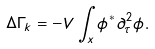<formula> <loc_0><loc_0><loc_500><loc_500>\Delta \Gamma _ { k } = - V \int _ { x } \phi ^ { * } \partial ^ { 2 } _ { \tau } \phi .</formula> 